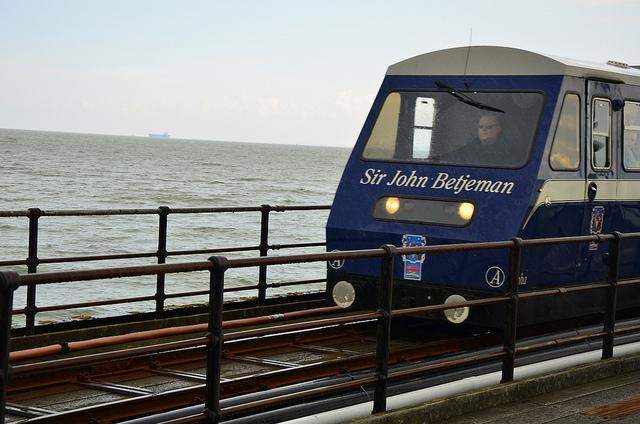What kind of transportation is present?
Answer briefly. Train. What is the first word on the train?
Short answer required. Sir. Is this a train?
Quick response, please. Yes. 